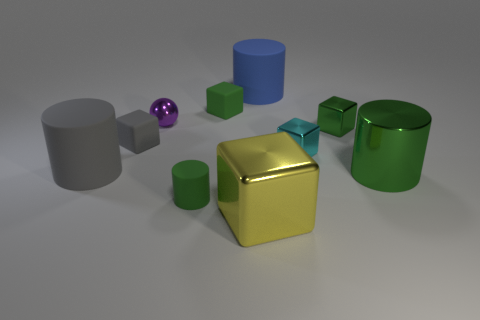How many other objects are the same size as the gray cube?
Give a very brief answer. 5. There is a tiny rubber thing that is in front of the large metal cylinder; is it the same color as the large shiny cylinder?
Your answer should be very brief. Yes. There is a matte cylinder that is on the right side of the tiny shiny ball and left of the large yellow block; what size is it?
Keep it short and to the point. Small. What number of small things are gray blocks or red rubber cylinders?
Ensure brevity in your answer.  1. What is the shape of the metallic object that is on the left side of the green matte cylinder?
Offer a very short reply. Sphere. What number of gray cylinders are there?
Give a very brief answer. 1. Does the tiny cyan block have the same material as the tiny ball?
Your answer should be compact. Yes. Is the number of small objects that are on the right side of the small green cylinder greater than the number of cylinders?
Your answer should be compact. No. How many objects are either brown rubber cubes or large matte objects on the left side of the small purple metal object?
Your answer should be compact. 1. Is the number of yellow cubes in front of the tiny gray matte cube greater than the number of big blue rubber cylinders in front of the large yellow thing?
Provide a succinct answer. Yes. 